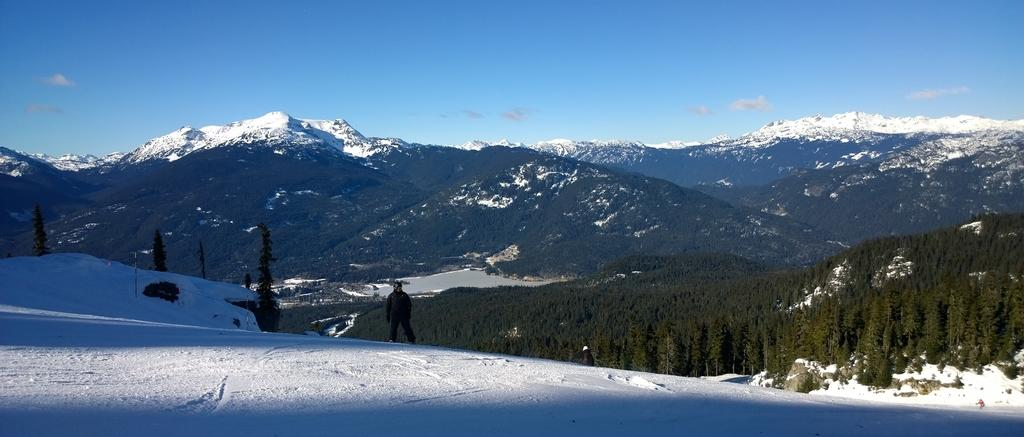What type of weather condition is depicted in the image? There is snow in the image, indicating a cold and wintry scene. What natural features can be seen in the image? There are mountains and trees in the image. What is visible in the sky in the image? The sky is visible in the image. Can you describe the person in the image? There is a person standing in the image. What type of science experiment is being conducted by the person in the image? There is no indication of a science experiment being conducted in the image; it simply shows a person standing amidst snow, mountains, and trees. Can you see a boat in the image? No, there is no boat present in the image. 